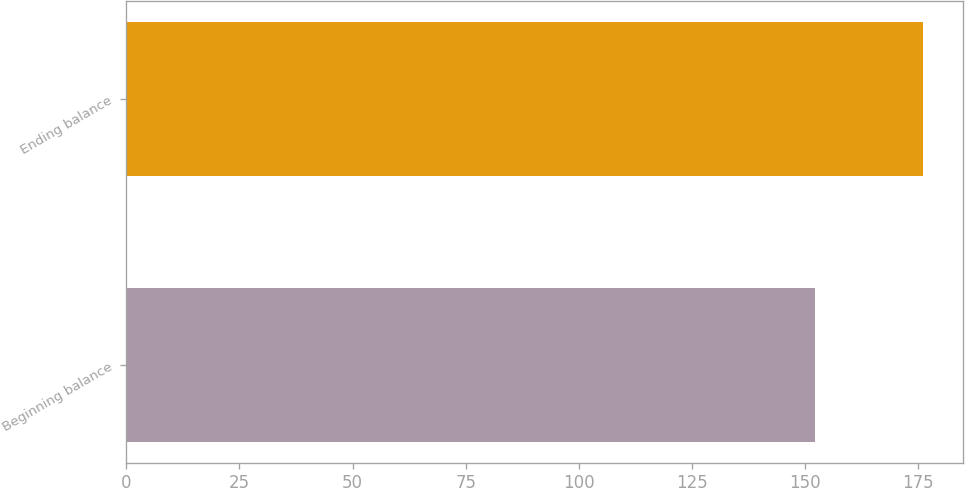Convert chart to OTSL. <chart><loc_0><loc_0><loc_500><loc_500><bar_chart><fcel>Beginning balance<fcel>Ending balance<nl><fcel>152.1<fcel>176.1<nl></chart> 